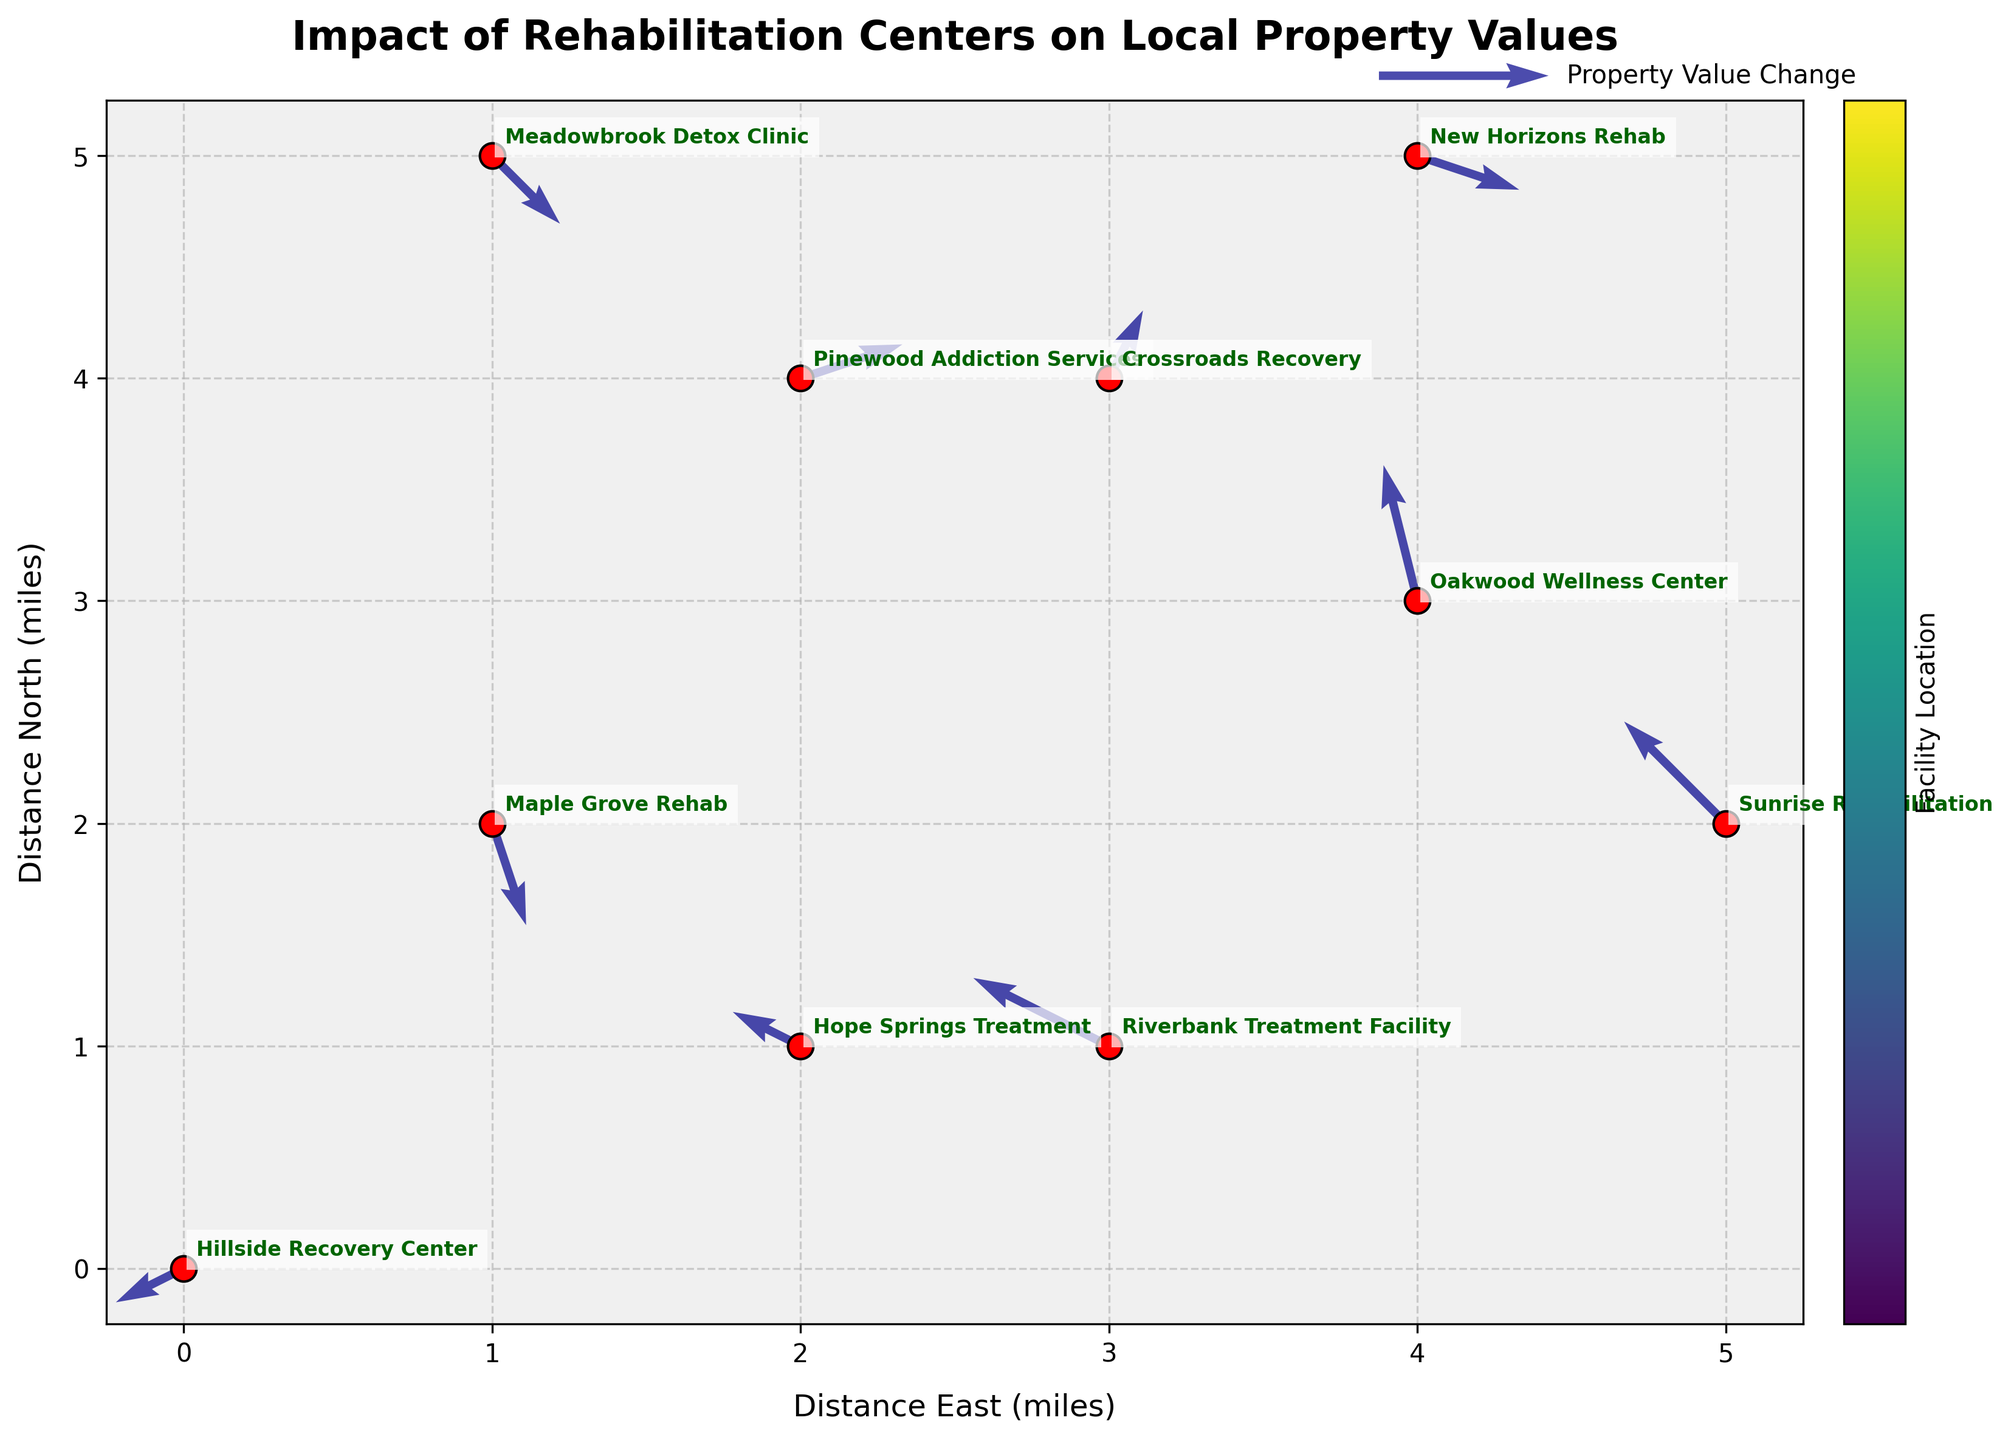what is the title of the plot? To find the title, look at the top of the plot where the title is usually placed. In this figure, it's written in bold. The title is "Impact of Rehabilitation Centers on Local Property Values".
Answer: Impact of Rehabilitation Centers on Local Property Values Which rehabilitation center is located farthest east? To determine which center is farthest east, check the `x` coordinates on the horizontal axis. The highest `x` value corresponds to the farthest east point. In this figure, the center with `x = 5` is Sunrise Rehabilitation.
Answer: Sunrise Rehabilitation How many rehabilitation centers are shown in the plot? Count the number of red dots or the names annotated next to the dots. There are 10 rehabilitation centers represented in the plot.
Answer: 10 Which facility shows the largest change in the north direction? The change in the north direction is represented by the `v` component of the quiver arrows. Look for the arrow with the largest upward or downward length. Oakwood Wellness Center has a `v` value of `0.4`, the largest in the dataset.
Answer: Oakwood Wellness Center What is the property value change direction near Maplegrove Rehab? To identify the direction of property value change near Maple Grove Rehab, find its position and observe the direction of its corresponding arrow. The arrow points down and slightly to the right indicating a negative change (-0.3) in the north direction and a positive change (0.1) in the east direction.
Answer: Downward and slightly to the right Which two facilities are closest to each other, based on their coordinates? To determine the closest facilities, we look for the smallest distance between two points on the plot. By evaluating the proximity of the points, Hope Springs Treatment and Riverbank Treatment Facility appear to be nearest to each other with overlapping or almost overlapping positions near coordinates (2, 1) and (3, 1).
Answer: Hope Springs Treatment and Riverbank Treatment Facility Which direction generally indicates a decrease in property values? In a quiver plot, downward-pointing arrows typically represent a decrease in values in the north direction, while left-pointing arrows represent a decrease in values in the east direction.
Answer: Downward and leftward What is the average eastward (x) coordinate of the facilities? Add up all the `x` coordinates and divide by the number of facilities. The sum of the `x` coordinates is (0 + 1 + 3 + 2 + 4 + 1 + 5 + 3 + 2 + 4) = 25. There are 10 facilities, so the average is 25/10 = 2.5.
Answer: 2.5 What is the most common direction of property value change indicated on the quiver plot? Examine the direction of the majority of the quiver arrows. Most arrows point towards the bottom or the left, suggesting a common direction of property value decrease either in the north or east direction.
Answer: Decrease 